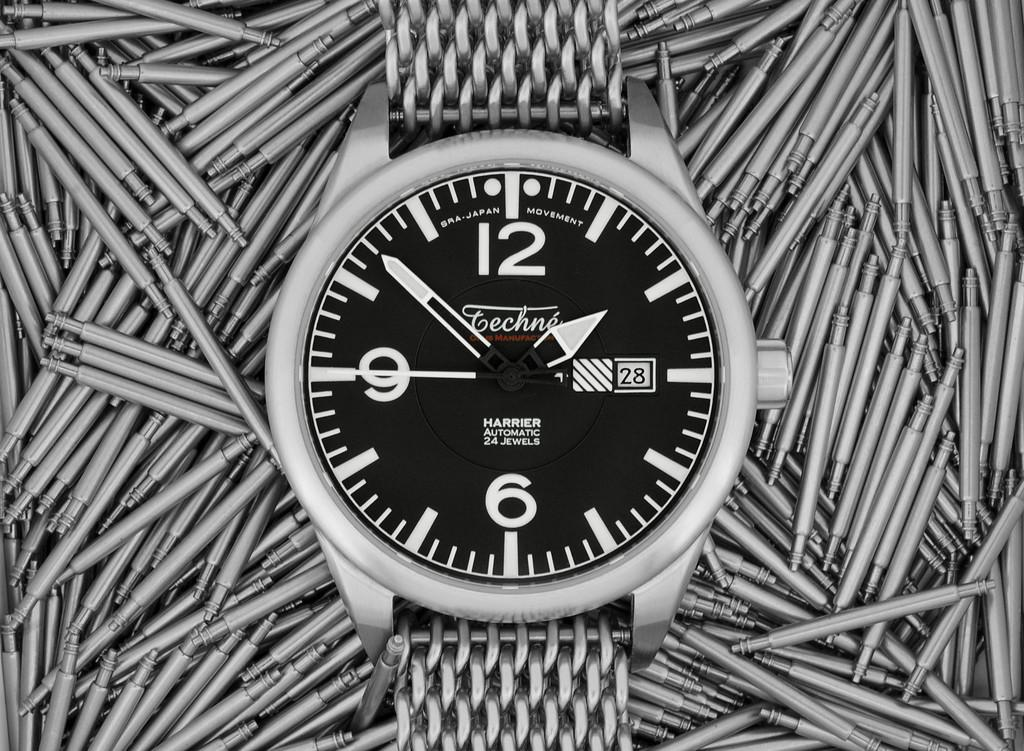Provide a one-sentence caption for the provided image. The stainless steel watch currently shows the time of 1:52 and the 28th day of the month. 